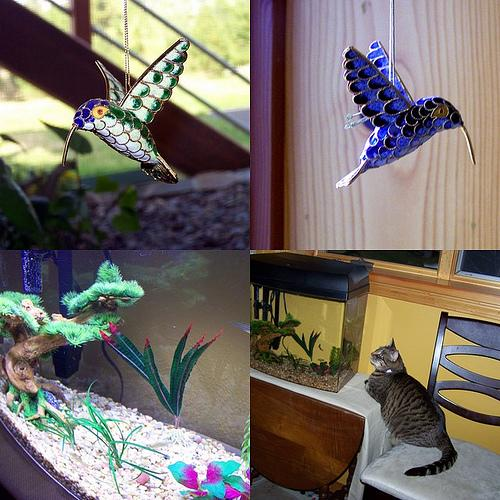What type of birds are in the top images? Please explain your reasoning. hummingbirds. These are small birds with long beaks used to get nectar from flowers 